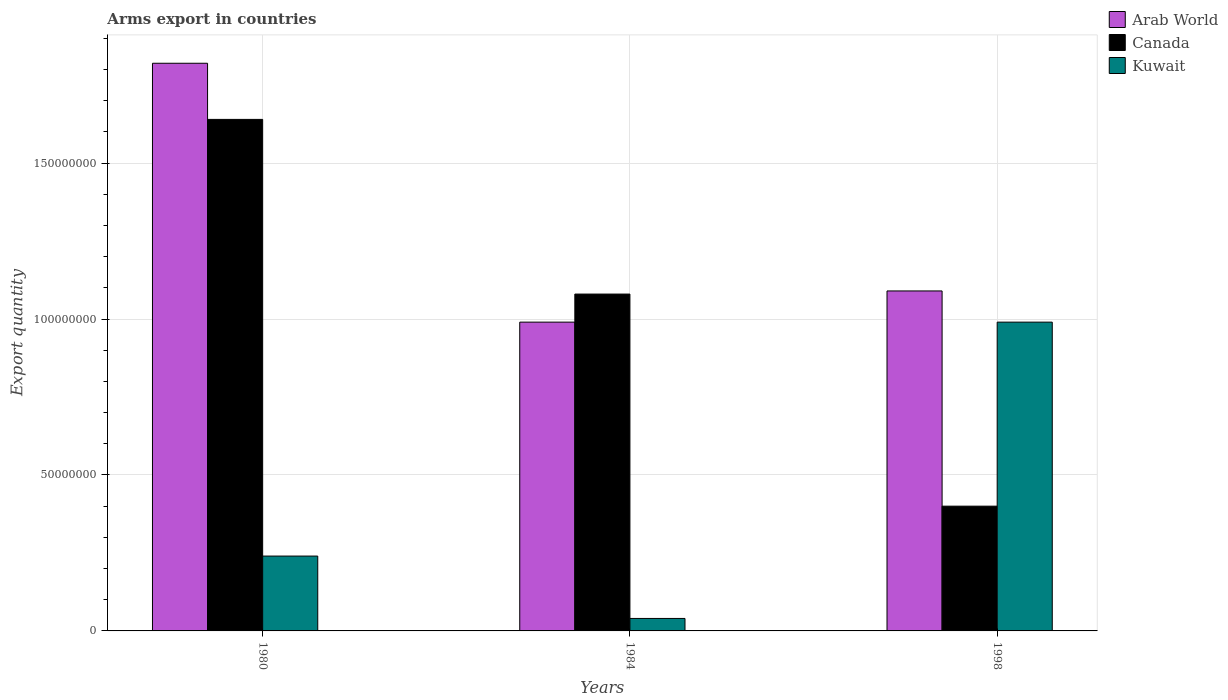How many groups of bars are there?
Keep it short and to the point. 3. How many bars are there on the 2nd tick from the left?
Make the answer very short. 3. What is the label of the 1st group of bars from the left?
Your response must be concise. 1980. In how many cases, is the number of bars for a given year not equal to the number of legend labels?
Offer a terse response. 0. What is the total arms export in Canada in 1980?
Offer a terse response. 1.64e+08. Across all years, what is the maximum total arms export in Arab World?
Your response must be concise. 1.82e+08. In which year was the total arms export in Arab World maximum?
Provide a succinct answer. 1980. What is the total total arms export in Canada in the graph?
Provide a short and direct response. 3.12e+08. What is the difference between the total arms export in Arab World in 1980 and that in 1984?
Provide a succinct answer. 8.30e+07. What is the difference between the total arms export in Canada in 1998 and the total arms export in Arab World in 1980?
Provide a succinct answer. -1.42e+08. What is the average total arms export in Arab World per year?
Provide a succinct answer. 1.30e+08. In the year 1984, what is the difference between the total arms export in Canada and total arms export in Kuwait?
Your answer should be compact. 1.04e+08. What is the ratio of the total arms export in Kuwait in 1980 to that in 1998?
Give a very brief answer. 0.24. Is the total arms export in Canada in 1980 less than that in 1984?
Keep it short and to the point. No. What is the difference between the highest and the second highest total arms export in Canada?
Your response must be concise. 5.60e+07. What is the difference between the highest and the lowest total arms export in Canada?
Make the answer very short. 1.24e+08. In how many years, is the total arms export in Canada greater than the average total arms export in Canada taken over all years?
Provide a succinct answer. 2. What does the 1st bar from the left in 1980 represents?
Give a very brief answer. Arab World. What does the 3rd bar from the right in 1998 represents?
Your response must be concise. Arab World. Is it the case that in every year, the sum of the total arms export in Arab World and total arms export in Canada is greater than the total arms export in Kuwait?
Your answer should be very brief. Yes. How many bars are there?
Make the answer very short. 9. How many years are there in the graph?
Make the answer very short. 3. Are the values on the major ticks of Y-axis written in scientific E-notation?
Provide a short and direct response. No. Does the graph contain any zero values?
Your answer should be compact. No. Where does the legend appear in the graph?
Keep it short and to the point. Top right. How are the legend labels stacked?
Make the answer very short. Vertical. What is the title of the graph?
Your response must be concise. Arms export in countries. Does "Bosnia and Herzegovina" appear as one of the legend labels in the graph?
Keep it short and to the point. No. What is the label or title of the Y-axis?
Offer a terse response. Export quantity. What is the Export quantity of Arab World in 1980?
Your answer should be compact. 1.82e+08. What is the Export quantity in Canada in 1980?
Offer a very short reply. 1.64e+08. What is the Export quantity in Kuwait in 1980?
Give a very brief answer. 2.40e+07. What is the Export quantity of Arab World in 1984?
Offer a terse response. 9.90e+07. What is the Export quantity in Canada in 1984?
Give a very brief answer. 1.08e+08. What is the Export quantity in Arab World in 1998?
Give a very brief answer. 1.09e+08. What is the Export quantity in Canada in 1998?
Keep it short and to the point. 4.00e+07. What is the Export quantity in Kuwait in 1998?
Your answer should be compact. 9.90e+07. Across all years, what is the maximum Export quantity of Arab World?
Your answer should be compact. 1.82e+08. Across all years, what is the maximum Export quantity of Canada?
Your response must be concise. 1.64e+08. Across all years, what is the maximum Export quantity of Kuwait?
Offer a terse response. 9.90e+07. Across all years, what is the minimum Export quantity of Arab World?
Give a very brief answer. 9.90e+07. Across all years, what is the minimum Export quantity of Canada?
Ensure brevity in your answer.  4.00e+07. Across all years, what is the minimum Export quantity in Kuwait?
Your answer should be very brief. 4.00e+06. What is the total Export quantity in Arab World in the graph?
Keep it short and to the point. 3.90e+08. What is the total Export quantity in Canada in the graph?
Offer a very short reply. 3.12e+08. What is the total Export quantity of Kuwait in the graph?
Make the answer very short. 1.27e+08. What is the difference between the Export quantity in Arab World in 1980 and that in 1984?
Ensure brevity in your answer.  8.30e+07. What is the difference between the Export quantity of Canada in 1980 and that in 1984?
Your answer should be very brief. 5.60e+07. What is the difference between the Export quantity of Kuwait in 1980 and that in 1984?
Give a very brief answer. 2.00e+07. What is the difference between the Export quantity of Arab World in 1980 and that in 1998?
Give a very brief answer. 7.30e+07. What is the difference between the Export quantity of Canada in 1980 and that in 1998?
Your answer should be compact. 1.24e+08. What is the difference between the Export quantity of Kuwait in 1980 and that in 1998?
Give a very brief answer. -7.50e+07. What is the difference between the Export quantity of Arab World in 1984 and that in 1998?
Ensure brevity in your answer.  -1.00e+07. What is the difference between the Export quantity of Canada in 1984 and that in 1998?
Your response must be concise. 6.80e+07. What is the difference between the Export quantity of Kuwait in 1984 and that in 1998?
Keep it short and to the point. -9.50e+07. What is the difference between the Export quantity in Arab World in 1980 and the Export quantity in Canada in 1984?
Make the answer very short. 7.40e+07. What is the difference between the Export quantity in Arab World in 1980 and the Export quantity in Kuwait in 1984?
Offer a terse response. 1.78e+08. What is the difference between the Export quantity in Canada in 1980 and the Export quantity in Kuwait in 1984?
Your answer should be compact. 1.60e+08. What is the difference between the Export quantity of Arab World in 1980 and the Export quantity of Canada in 1998?
Keep it short and to the point. 1.42e+08. What is the difference between the Export quantity of Arab World in 1980 and the Export quantity of Kuwait in 1998?
Your answer should be compact. 8.30e+07. What is the difference between the Export quantity in Canada in 1980 and the Export quantity in Kuwait in 1998?
Your answer should be very brief. 6.50e+07. What is the difference between the Export quantity of Arab World in 1984 and the Export quantity of Canada in 1998?
Your answer should be compact. 5.90e+07. What is the difference between the Export quantity in Canada in 1984 and the Export quantity in Kuwait in 1998?
Provide a succinct answer. 9.00e+06. What is the average Export quantity in Arab World per year?
Offer a very short reply. 1.30e+08. What is the average Export quantity in Canada per year?
Your answer should be very brief. 1.04e+08. What is the average Export quantity in Kuwait per year?
Provide a succinct answer. 4.23e+07. In the year 1980, what is the difference between the Export quantity in Arab World and Export quantity in Canada?
Make the answer very short. 1.80e+07. In the year 1980, what is the difference between the Export quantity in Arab World and Export quantity in Kuwait?
Your response must be concise. 1.58e+08. In the year 1980, what is the difference between the Export quantity in Canada and Export quantity in Kuwait?
Your answer should be very brief. 1.40e+08. In the year 1984, what is the difference between the Export quantity of Arab World and Export quantity of Canada?
Ensure brevity in your answer.  -9.00e+06. In the year 1984, what is the difference between the Export quantity in Arab World and Export quantity in Kuwait?
Your answer should be very brief. 9.50e+07. In the year 1984, what is the difference between the Export quantity in Canada and Export quantity in Kuwait?
Give a very brief answer. 1.04e+08. In the year 1998, what is the difference between the Export quantity of Arab World and Export quantity of Canada?
Offer a terse response. 6.90e+07. In the year 1998, what is the difference between the Export quantity of Arab World and Export quantity of Kuwait?
Keep it short and to the point. 1.00e+07. In the year 1998, what is the difference between the Export quantity in Canada and Export quantity in Kuwait?
Give a very brief answer. -5.90e+07. What is the ratio of the Export quantity in Arab World in 1980 to that in 1984?
Offer a terse response. 1.84. What is the ratio of the Export quantity in Canada in 1980 to that in 1984?
Your response must be concise. 1.52. What is the ratio of the Export quantity in Kuwait in 1980 to that in 1984?
Provide a short and direct response. 6. What is the ratio of the Export quantity of Arab World in 1980 to that in 1998?
Make the answer very short. 1.67. What is the ratio of the Export quantity of Kuwait in 1980 to that in 1998?
Give a very brief answer. 0.24. What is the ratio of the Export quantity in Arab World in 1984 to that in 1998?
Your answer should be compact. 0.91. What is the ratio of the Export quantity of Kuwait in 1984 to that in 1998?
Ensure brevity in your answer.  0.04. What is the difference between the highest and the second highest Export quantity of Arab World?
Your answer should be very brief. 7.30e+07. What is the difference between the highest and the second highest Export quantity in Canada?
Ensure brevity in your answer.  5.60e+07. What is the difference between the highest and the second highest Export quantity in Kuwait?
Provide a succinct answer. 7.50e+07. What is the difference between the highest and the lowest Export quantity of Arab World?
Offer a terse response. 8.30e+07. What is the difference between the highest and the lowest Export quantity of Canada?
Your answer should be compact. 1.24e+08. What is the difference between the highest and the lowest Export quantity of Kuwait?
Your answer should be very brief. 9.50e+07. 